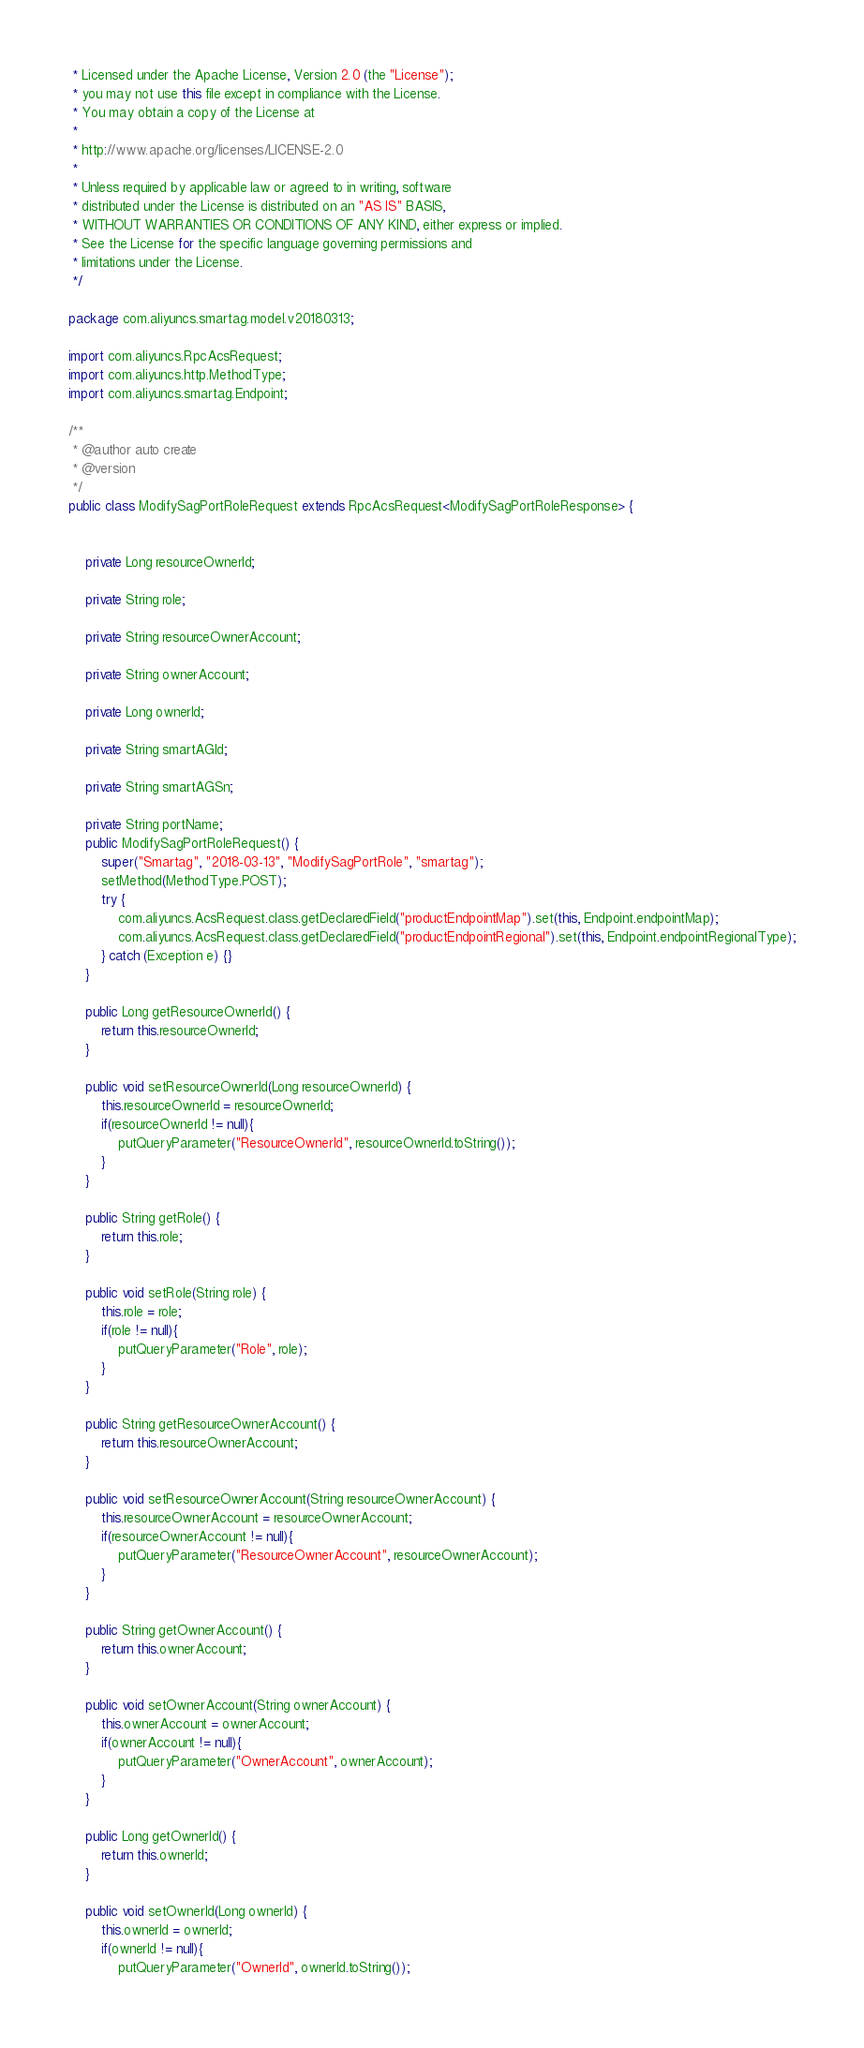Convert code to text. <code><loc_0><loc_0><loc_500><loc_500><_Java_> * Licensed under the Apache License, Version 2.0 (the "License");
 * you may not use this file except in compliance with the License.
 * You may obtain a copy of the License at
 *
 * http://www.apache.org/licenses/LICENSE-2.0
 *
 * Unless required by applicable law or agreed to in writing, software
 * distributed under the License is distributed on an "AS IS" BASIS,
 * WITHOUT WARRANTIES OR CONDITIONS OF ANY KIND, either express or implied.
 * See the License for the specific language governing permissions and
 * limitations under the License.
 */

package com.aliyuncs.smartag.model.v20180313;

import com.aliyuncs.RpcAcsRequest;
import com.aliyuncs.http.MethodType;
import com.aliyuncs.smartag.Endpoint;

/**
 * @author auto create
 * @version 
 */
public class ModifySagPortRoleRequest extends RpcAcsRequest<ModifySagPortRoleResponse> {
	   

	private Long resourceOwnerId;

	private String role;

	private String resourceOwnerAccount;

	private String ownerAccount;

	private Long ownerId;

	private String smartAGId;

	private String smartAGSn;

	private String portName;
	public ModifySagPortRoleRequest() {
		super("Smartag", "2018-03-13", "ModifySagPortRole", "smartag");
		setMethod(MethodType.POST);
		try {
			com.aliyuncs.AcsRequest.class.getDeclaredField("productEndpointMap").set(this, Endpoint.endpointMap);
			com.aliyuncs.AcsRequest.class.getDeclaredField("productEndpointRegional").set(this, Endpoint.endpointRegionalType);
		} catch (Exception e) {}
	}

	public Long getResourceOwnerId() {
		return this.resourceOwnerId;
	}

	public void setResourceOwnerId(Long resourceOwnerId) {
		this.resourceOwnerId = resourceOwnerId;
		if(resourceOwnerId != null){
			putQueryParameter("ResourceOwnerId", resourceOwnerId.toString());
		}
	}

	public String getRole() {
		return this.role;
	}

	public void setRole(String role) {
		this.role = role;
		if(role != null){
			putQueryParameter("Role", role);
		}
	}

	public String getResourceOwnerAccount() {
		return this.resourceOwnerAccount;
	}

	public void setResourceOwnerAccount(String resourceOwnerAccount) {
		this.resourceOwnerAccount = resourceOwnerAccount;
		if(resourceOwnerAccount != null){
			putQueryParameter("ResourceOwnerAccount", resourceOwnerAccount);
		}
	}

	public String getOwnerAccount() {
		return this.ownerAccount;
	}

	public void setOwnerAccount(String ownerAccount) {
		this.ownerAccount = ownerAccount;
		if(ownerAccount != null){
			putQueryParameter("OwnerAccount", ownerAccount);
		}
	}

	public Long getOwnerId() {
		return this.ownerId;
	}

	public void setOwnerId(Long ownerId) {
		this.ownerId = ownerId;
		if(ownerId != null){
			putQueryParameter("OwnerId", ownerId.toString());</code> 